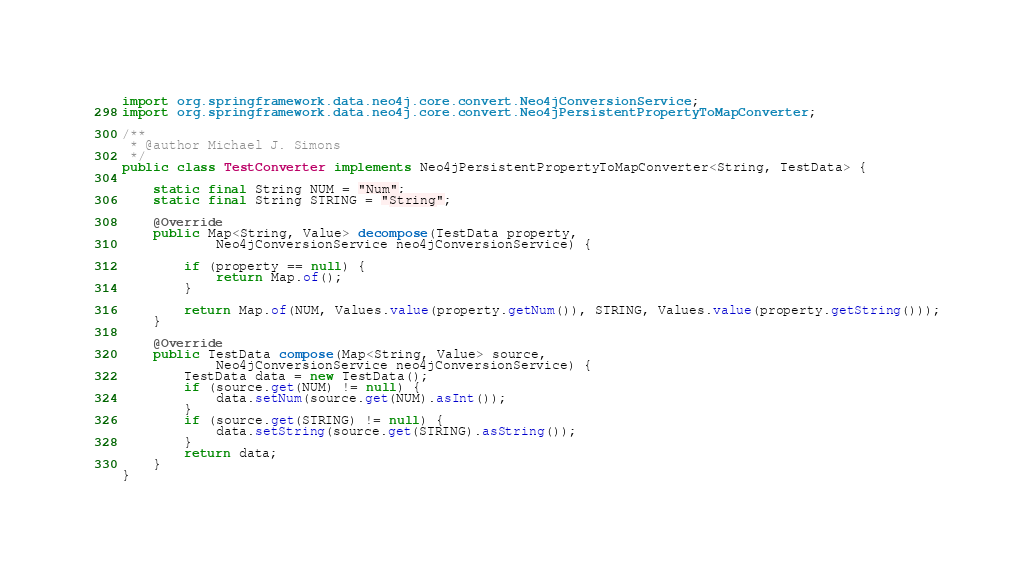Convert code to text. <code><loc_0><loc_0><loc_500><loc_500><_Java_>import org.springframework.data.neo4j.core.convert.Neo4jConversionService;
import org.springframework.data.neo4j.core.convert.Neo4jPersistentPropertyToMapConverter;

/**
 * @author Michael J. Simons
 */
public class TestConverter implements Neo4jPersistentPropertyToMapConverter<String, TestData> {

	static final String NUM = "Num";
	static final String STRING = "String";

	@Override
	public Map<String, Value> decompose(TestData property,
			Neo4jConversionService neo4jConversionService) {

		if (property == null) {
			return Map.of();
		}

		return Map.of(NUM, Values.value(property.getNum()), STRING, Values.value(property.getString()));
	}

	@Override
	public TestData compose(Map<String, Value> source,
			Neo4jConversionService neo4jConversionService) {
		TestData data = new TestData();
		if (source.get(NUM) != null) {
			data.setNum(source.get(NUM).asInt());
		}
		if (source.get(STRING) != null) {
			data.setString(source.get(STRING).asString());
		}
		return data;
	}
}
</code> 